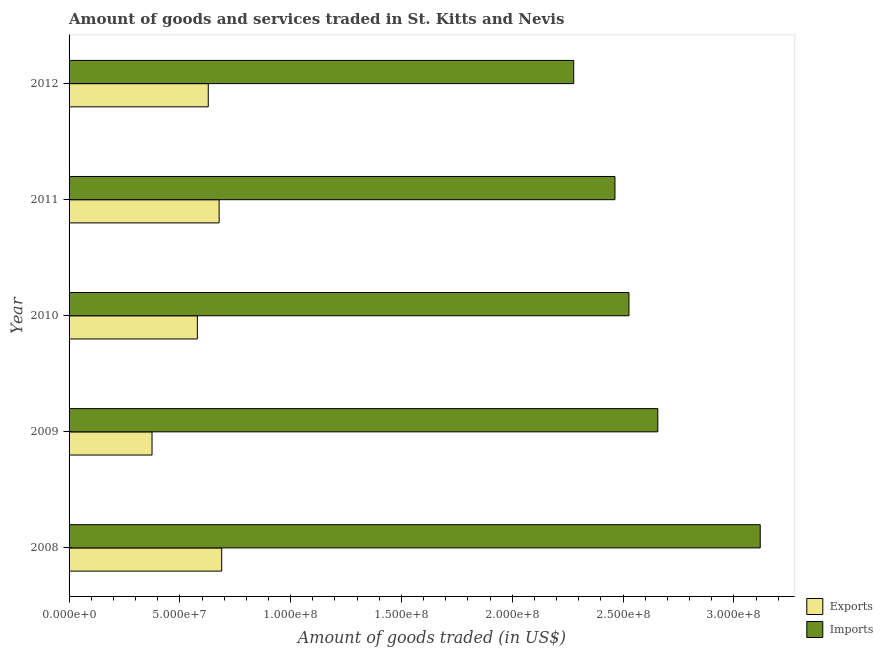How many different coloured bars are there?
Provide a succinct answer. 2. How many groups of bars are there?
Offer a terse response. 5. Are the number of bars per tick equal to the number of legend labels?
Offer a terse response. Yes. Are the number of bars on each tick of the Y-axis equal?
Provide a succinct answer. Yes. How many bars are there on the 2nd tick from the top?
Make the answer very short. 2. What is the label of the 1st group of bars from the top?
Offer a very short reply. 2012. In how many cases, is the number of bars for a given year not equal to the number of legend labels?
Your response must be concise. 0. What is the amount of goods exported in 2009?
Offer a terse response. 3.74e+07. Across all years, what is the maximum amount of goods imported?
Your answer should be very brief. 3.12e+08. Across all years, what is the minimum amount of goods imported?
Your response must be concise. 2.28e+08. In which year was the amount of goods exported minimum?
Your answer should be compact. 2009. What is the total amount of goods exported in the graph?
Keep it short and to the point. 2.95e+08. What is the difference between the amount of goods imported in 2008 and that in 2011?
Your answer should be very brief. 6.56e+07. What is the difference between the amount of goods imported in 2010 and the amount of goods exported in 2011?
Your answer should be compact. 1.85e+08. What is the average amount of goods exported per year?
Your answer should be very brief. 5.89e+07. In the year 2010, what is the difference between the amount of goods exported and amount of goods imported?
Your response must be concise. -1.95e+08. In how many years, is the amount of goods exported greater than 300000000 US$?
Provide a succinct answer. 0. What is the ratio of the amount of goods imported in 2011 to that in 2012?
Provide a succinct answer. 1.08. Is the amount of goods exported in 2010 less than that in 2011?
Your answer should be compact. Yes. Is the difference between the amount of goods exported in 2008 and 2011 greater than the difference between the amount of goods imported in 2008 and 2011?
Give a very brief answer. No. What is the difference between the highest and the second highest amount of goods imported?
Offer a very short reply. 4.62e+07. What is the difference between the highest and the lowest amount of goods imported?
Offer a very short reply. 8.42e+07. Is the sum of the amount of goods imported in 2011 and 2012 greater than the maximum amount of goods exported across all years?
Your response must be concise. Yes. What does the 1st bar from the top in 2012 represents?
Provide a short and direct response. Imports. What does the 2nd bar from the bottom in 2010 represents?
Provide a succinct answer. Imports. How many years are there in the graph?
Provide a succinct answer. 5. Are the values on the major ticks of X-axis written in scientific E-notation?
Ensure brevity in your answer.  Yes. Does the graph contain any zero values?
Your answer should be compact. No. Does the graph contain grids?
Offer a very short reply. No. Where does the legend appear in the graph?
Provide a succinct answer. Bottom right. How many legend labels are there?
Give a very brief answer. 2. How are the legend labels stacked?
Keep it short and to the point. Vertical. What is the title of the graph?
Your response must be concise. Amount of goods and services traded in St. Kitts and Nevis. What is the label or title of the X-axis?
Provide a short and direct response. Amount of goods traded (in US$). What is the label or title of the Y-axis?
Provide a succinct answer. Year. What is the Amount of goods traded (in US$) in Exports in 2008?
Keep it short and to the point. 6.89e+07. What is the Amount of goods traded (in US$) in Imports in 2008?
Give a very brief answer. 3.12e+08. What is the Amount of goods traded (in US$) in Exports in 2009?
Give a very brief answer. 3.74e+07. What is the Amount of goods traded (in US$) in Imports in 2009?
Offer a terse response. 2.66e+08. What is the Amount of goods traded (in US$) of Exports in 2010?
Your answer should be compact. 5.79e+07. What is the Amount of goods traded (in US$) of Imports in 2010?
Offer a terse response. 2.53e+08. What is the Amount of goods traded (in US$) in Exports in 2011?
Offer a very short reply. 6.77e+07. What is the Amount of goods traded (in US$) in Imports in 2011?
Your response must be concise. 2.46e+08. What is the Amount of goods traded (in US$) of Exports in 2012?
Your answer should be very brief. 6.28e+07. What is the Amount of goods traded (in US$) in Imports in 2012?
Your answer should be compact. 2.28e+08. Across all years, what is the maximum Amount of goods traded (in US$) of Exports?
Offer a very short reply. 6.89e+07. Across all years, what is the maximum Amount of goods traded (in US$) in Imports?
Keep it short and to the point. 3.12e+08. Across all years, what is the minimum Amount of goods traded (in US$) in Exports?
Provide a short and direct response. 3.74e+07. Across all years, what is the minimum Amount of goods traded (in US$) in Imports?
Provide a succinct answer. 2.28e+08. What is the total Amount of goods traded (in US$) in Exports in the graph?
Your answer should be compact. 2.95e+08. What is the total Amount of goods traded (in US$) in Imports in the graph?
Ensure brevity in your answer.  1.30e+09. What is the difference between the Amount of goods traded (in US$) of Exports in 2008 and that in 2009?
Provide a succinct answer. 3.14e+07. What is the difference between the Amount of goods traded (in US$) in Imports in 2008 and that in 2009?
Offer a terse response. 4.62e+07. What is the difference between the Amount of goods traded (in US$) of Exports in 2008 and that in 2010?
Ensure brevity in your answer.  1.10e+07. What is the difference between the Amount of goods traded (in US$) of Imports in 2008 and that in 2010?
Your answer should be very brief. 5.92e+07. What is the difference between the Amount of goods traded (in US$) of Exports in 2008 and that in 2011?
Provide a succinct answer. 1.15e+06. What is the difference between the Amount of goods traded (in US$) of Imports in 2008 and that in 2011?
Your response must be concise. 6.56e+07. What is the difference between the Amount of goods traded (in US$) in Exports in 2008 and that in 2012?
Keep it short and to the point. 6.05e+06. What is the difference between the Amount of goods traded (in US$) in Imports in 2008 and that in 2012?
Your response must be concise. 8.42e+07. What is the difference between the Amount of goods traded (in US$) of Exports in 2009 and that in 2010?
Offer a terse response. -2.05e+07. What is the difference between the Amount of goods traded (in US$) in Imports in 2009 and that in 2010?
Offer a very short reply. 1.30e+07. What is the difference between the Amount of goods traded (in US$) of Exports in 2009 and that in 2011?
Your response must be concise. -3.03e+07. What is the difference between the Amount of goods traded (in US$) of Imports in 2009 and that in 2011?
Provide a short and direct response. 1.93e+07. What is the difference between the Amount of goods traded (in US$) of Exports in 2009 and that in 2012?
Your answer should be very brief. -2.54e+07. What is the difference between the Amount of goods traded (in US$) of Imports in 2009 and that in 2012?
Keep it short and to the point. 3.79e+07. What is the difference between the Amount of goods traded (in US$) in Exports in 2010 and that in 2011?
Keep it short and to the point. -9.81e+06. What is the difference between the Amount of goods traded (in US$) of Imports in 2010 and that in 2011?
Offer a very short reply. 6.32e+06. What is the difference between the Amount of goods traded (in US$) in Exports in 2010 and that in 2012?
Provide a short and direct response. -4.91e+06. What is the difference between the Amount of goods traded (in US$) of Imports in 2010 and that in 2012?
Provide a short and direct response. 2.49e+07. What is the difference between the Amount of goods traded (in US$) of Exports in 2011 and that in 2012?
Ensure brevity in your answer.  4.90e+06. What is the difference between the Amount of goods traded (in US$) in Imports in 2011 and that in 2012?
Offer a very short reply. 1.86e+07. What is the difference between the Amount of goods traded (in US$) of Exports in 2008 and the Amount of goods traded (in US$) of Imports in 2009?
Give a very brief answer. -1.97e+08. What is the difference between the Amount of goods traded (in US$) of Exports in 2008 and the Amount of goods traded (in US$) of Imports in 2010?
Provide a succinct answer. -1.84e+08. What is the difference between the Amount of goods traded (in US$) in Exports in 2008 and the Amount of goods traded (in US$) in Imports in 2011?
Your response must be concise. -1.77e+08. What is the difference between the Amount of goods traded (in US$) in Exports in 2008 and the Amount of goods traded (in US$) in Imports in 2012?
Your answer should be compact. -1.59e+08. What is the difference between the Amount of goods traded (in US$) in Exports in 2009 and the Amount of goods traded (in US$) in Imports in 2010?
Make the answer very short. -2.15e+08. What is the difference between the Amount of goods traded (in US$) of Exports in 2009 and the Amount of goods traded (in US$) of Imports in 2011?
Your answer should be very brief. -2.09e+08. What is the difference between the Amount of goods traded (in US$) of Exports in 2009 and the Amount of goods traded (in US$) of Imports in 2012?
Offer a very short reply. -1.90e+08. What is the difference between the Amount of goods traded (in US$) of Exports in 2010 and the Amount of goods traded (in US$) of Imports in 2011?
Make the answer very short. -1.88e+08. What is the difference between the Amount of goods traded (in US$) in Exports in 2010 and the Amount of goods traded (in US$) in Imports in 2012?
Provide a succinct answer. -1.70e+08. What is the difference between the Amount of goods traded (in US$) in Exports in 2011 and the Amount of goods traded (in US$) in Imports in 2012?
Make the answer very short. -1.60e+08. What is the average Amount of goods traded (in US$) of Exports per year?
Your answer should be compact. 5.89e+07. What is the average Amount of goods traded (in US$) of Imports per year?
Ensure brevity in your answer.  2.61e+08. In the year 2008, what is the difference between the Amount of goods traded (in US$) of Exports and Amount of goods traded (in US$) of Imports?
Your answer should be compact. -2.43e+08. In the year 2009, what is the difference between the Amount of goods traded (in US$) of Exports and Amount of goods traded (in US$) of Imports?
Keep it short and to the point. -2.28e+08. In the year 2010, what is the difference between the Amount of goods traded (in US$) of Exports and Amount of goods traded (in US$) of Imports?
Offer a terse response. -1.95e+08. In the year 2011, what is the difference between the Amount of goods traded (in US$) of Exports and Amount of goods traded (in US$) of Imports?
Ensure brevity in your answer.  -1.79e+08. In the year 2012, what is the difference between the Amount of goods traded (in US$) in Exports and Amount of goods traded (in US$) in Imports?
Your response must be concise. -1.65e+08. What is the ratio of the Amount of goods traded (in US$) of Exports in 2008 to that in 2009?
Your answer should be very brief. 1.84. What is the ratio of the Amount of goods traded (in US$) of Imports in 2008 to that in 2009?
Keep it short and to the point. 1.17. What is the ratio of the Amount of goods traded (in US$) of Exports in 2008 to that in 2010?
Provide a short and direct response. 1.19. What is the ratio of the Amount of goods traded (in US$) of Imports in 2008 to that in 2010?
Your answer should be compact. 1.23. What is the ratio of the Amount of goods traded (in US$) in Imports in 2008 to that in 2011?
Ensure brevity in your answer.  1.27. What is the ratio of the Amount of goods traded (in US$) in Exports in 2008 to that in 2012?
Your answer should be very brief. 1.1. What is the ratio of the Amount of goods traded (in US$) of Imports in 2008 to that in 2012?
Give a very brief answer. 1.37. What is the ratio of the Amount of goods traded (in US$) in Exports in 2009 to that in 2010?
Offer a terse response. 0.65. What is the ratio of the Amount of goods traded (in US$) of Imports in 2009 to that in 2010?
Provide a short and direct response. 1.05. What is the ratio of the Amount of goods traded (in US$) in Exports in 2009 to that in 2011?
Offer a very short reply. 0.55. What is the ratio of the Amount of goods traded (in US$) of Imports in 2009 to that in 2011?
Give a very brief answer. 1.08. What is the ratio of the Amount of goods traded (in US$) of Exports in 2009 to that in 2012?
Your answer should be very brief. 0.6. What is the ratio of the Amount of goods traded (in US$) of Imports in 2009 to that in 2012?
Offer a terse response. 1.17. What is the ratio of the Amount of goods traded (in US$) of Exports in 2010 to that in 2011?
Your answer should be compact. 0.86. What is the ratio of the Amount of goods traded (in US$) of Imports in 2010 to that in 2011?
Offer a terse response. 1.03. What is the ratio of the Amount of goods traded (in US$) of Exports in 2010 to that in 2012?
Your answer should be very brief. 0.92. What is the ratio of the Amount of goods traded (in US$) in Imports in 2010 to that in 2012?
Provide a succinct answer. 1.11. What is the ratio of the Amount of goods traded (in US$) of Exports in 2011 to that in 2012?
Ensure brevity in your answer.  1.08. What is the ratio of the Amount of goods traded (in US$) in Imports in 2011 to that in 2012?
Make the answer very short. 1.08. What is the difference between the highest and the second highest Amount of goods traded (in US$) in Exports?
Make the answer very short. 1.15e+06. What is the difference between the highest and the second highest Amount of goods traded (in US$) of Imports?
Your answer should be very brief. 4.62e+07. What is the difference between the highest and the lowest Amount of goods traded (in US$) of Exports?
Your response must be concise. 3.14e+07. What is the difference between the highest and the lowest Amount of goods traded (in US$) in Imports?
Make the answer very short. 8.42e+07. 